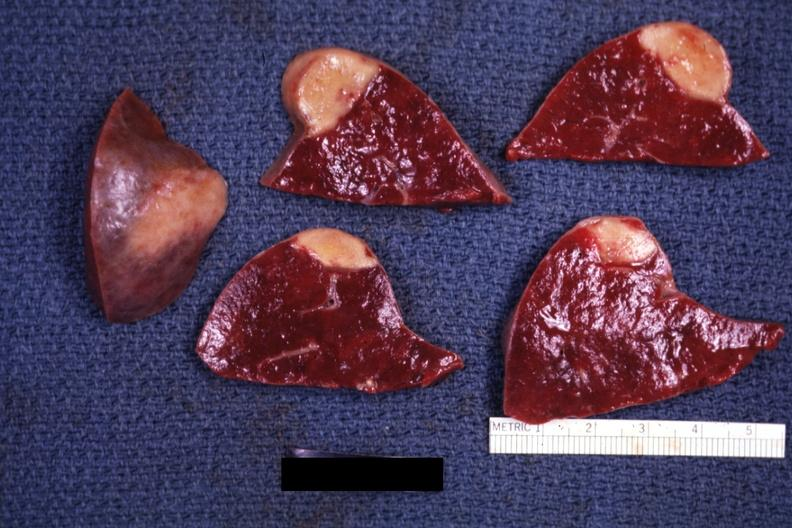does arcus senilis show several slices with obvious lesion and one external view excellent example?
Answer the question using a single word or phrase. No 